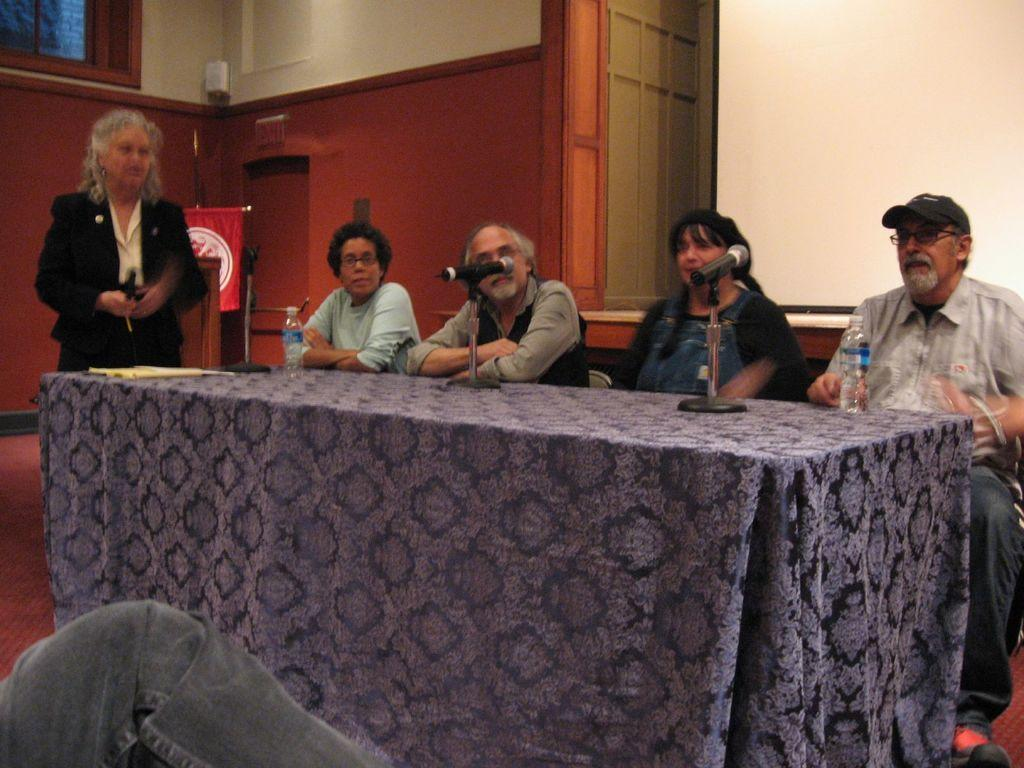What is the position of the woman in the image? The woman is standing on the left side of the image. What is the woman wearing in the image? The woman is wearing a coat in the image. How many persons are sitting in the image? There are four persons sitting on chairs in the image. What can be seen on the table in the image? There are two water bottles on a table in the image. What level of expertise does the woman have in writing prose in the image? There is no indication of the woman's writing abilities or any prose in the image. Is the station where the woman is standing visible in the image? There is no mention of a station in the image, only a woman standing on the left side. 